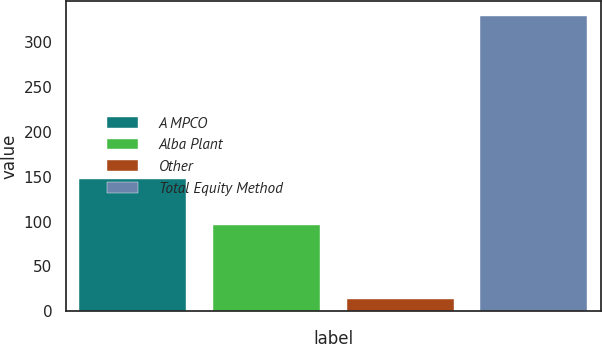<chart> <loc_0><loc_0><loc_500><loc_500><bar_chart><fcel>A MPCO<fcel>Alba Plant<fcel>Other<fcel>Total Equity Method<nl><fcel>147<fcel>96<fcel>14<fcel>329<nl></chart> 